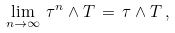Convert formula to latex. <formula><loc_0><loc_0><loc_500><loc_500>\lim _ { n \to \infty } \, \tau ^ { n } \wedge T \, = \, \tau \wedge T \, ,</formula> 